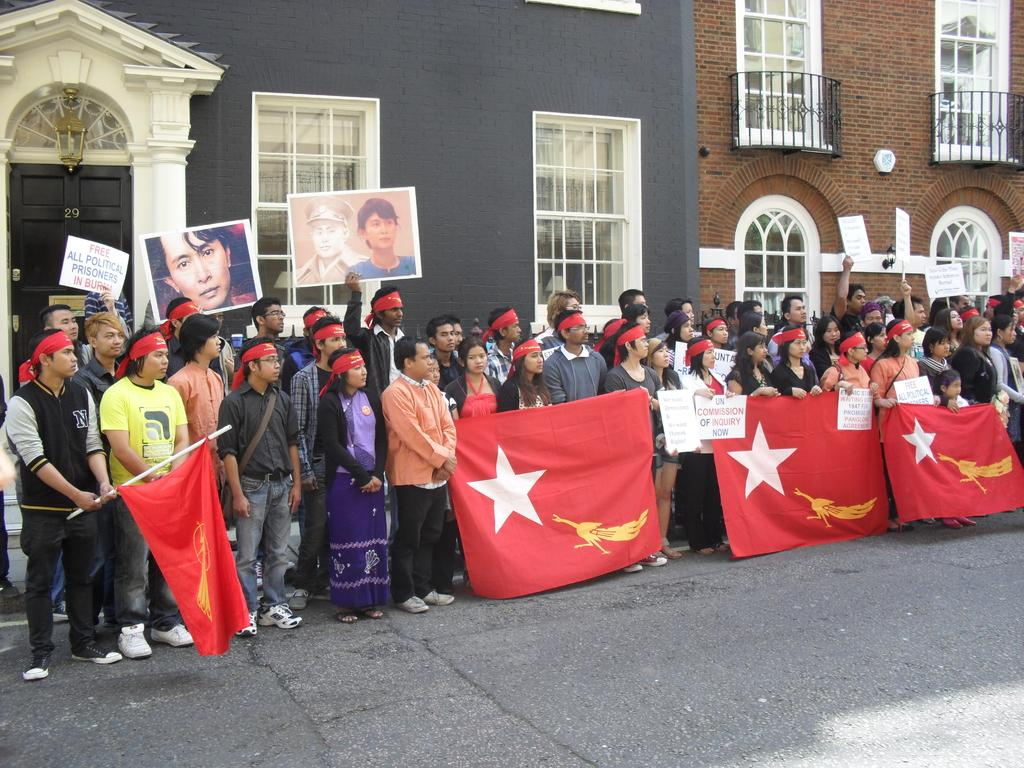What are the people in the center of the image doing? The people in the center of the image are holding flags. What is located at the bottom of the image? There is a road at the bottom of the image. What can be seen in the background of the image? There are buildings in the background of the image. What feature do the buildings have? The buildings have windows. What year is depicted in the image? The provided facts do not give any information about the year, so it cannot be determined from the image. How can the frame of the image be adjusted? The frame of the image is not present in the image itself, as it is a separate aspect of displaying the image. 